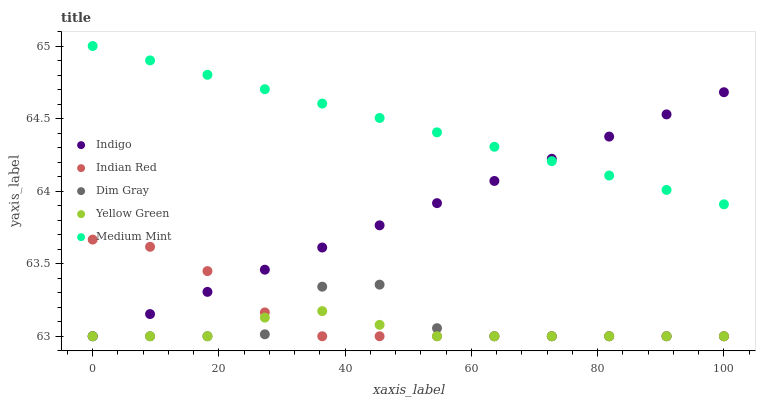Does Yellow Green have the minimum area under the curve?
Answer yes or no. Yes. Does Medium Mint have the maximum area under the curve?
Answer yes or no. Yes. Does Dim Gray have the minimum area under the curve?
Answer yes or no. No. Does Dim Gray have the maximum area under the curve?
Answer yes or no. No. Is Indigo the smoothest?
Answer yes or no. Yes. Is Dim Gray the roughest?
Answer yes or no. Yes. Is Dim Gray the smoothest?
Answer yes or no. No. Is Indigo the roughest?
Answer yes or no. No. Does Dim Gray have the lowest value?
Answer yes or no. Yes. Does Medium Mint have the highest value?
Answer yes or no. Yes. Does Dim Gray have the highest value?
Answer yes or no. No. Is Indian Red less than Medium Mint?
Answer yes or no. Yes. Is Medium Mint greater than Dim Gray?
Answer yes or no. Yes. Does Indigo intersect Medium Mint?
Answer yes or no. Yes. Is Indigo less than Medium Mint?
Answer yes or no. No. Is Indigo greater than Medium Mint?
Answer yes or no. No. Does Indian Red intersect Medium Mint?
Answer yes or no. No. 